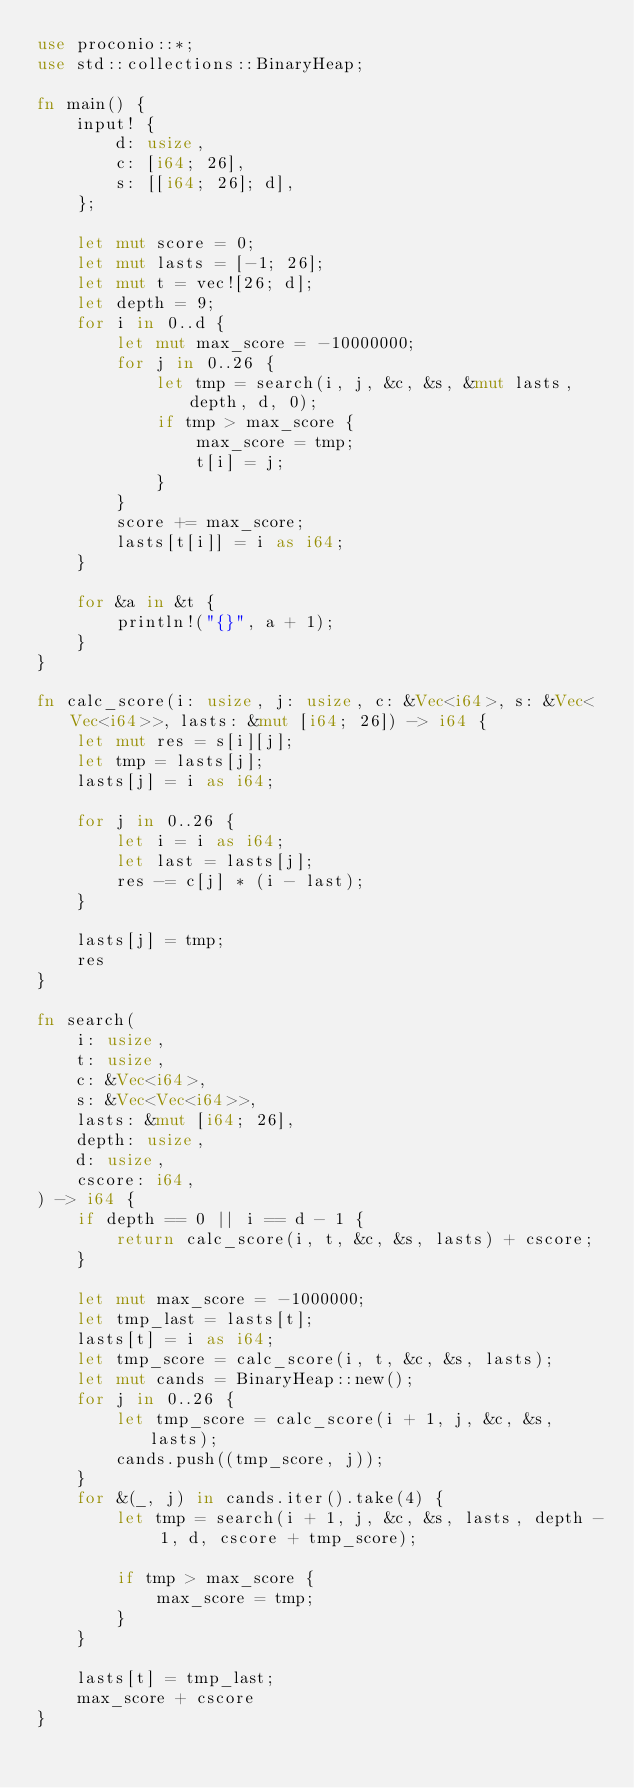Convert code to text. <code><loc_0><loc_0><loc_500><loc_500><_Rust_>use proconio::*;
use std::collections::BinaryHeap;

fn main() {
    input! {
        d: usize,
        c: [i64; 26],
        s: [[i64; 26]; d],
    };

    let mut score = 0;
    let mut lasts = [-1; 26];
    let mut t = vec![26; d];
    let depth = 9;
    for i in 0..d {
        let mut max_score = -10000000;
        for j in 0..26 {
            let tmp = search(i, j, &c, &s, &mut lasts, depth, d, 0);
            if tmp > max_score {
                max_score = tmp;
                t[i] = j;
            }
        }
        score += max_score;
        lasts[t[i]] = i as i64;
    }

    for &a in &t {
        println!("{}", a + 1);
    }
}

fn calc_score(i: usize, j: usize, c: &Vec<i64>, s: &Vec<Vec<i64>>, lasts: &mut [i64; 26]) -> i64 {
    let mut res = s[i][j];
    let tmp = lasts[j];
    lasts[j] = i as i64;

    for j in 0..26 {
        let i = i as i64;
        let last = lasts[j];
        res -= c[j] * (i - last);
    }

    lasts[j] = tmp;
    res
}

fn search(
    i: usize,
    t: usize,
    c: &Vec<i64>,
    s: &Vec<Vec<i64>>,
    lasts: &mut [i64; 26],
    depth: usize,
    d: usize,
    cscore: i64,
) -> i64 {
    if depth == 0 || i == d - 1 {
        return calc_score(i, t, &c, &s, lasts) + cscore;
    }

    let mut max_score = -1000000;
    let tmp_last = lasts[t];
    lasts[t] = i as i64;
    let tmp_score = calc_score(i, t, &c, &s, lasts);
    let mut cands = BinaryHeap::new();
    for j in 0..26 {
        let tmp_score = calc_score(i + 1, j, &c, &s, lasts);
        cands.push((tmp_score, j));
    }
    for &(_, j) in cands.iter().take(4) {
        let tmp = search(i + 1, j, &c, &s, lasts, depth - 1, d, cscore + tmp_score);

        if tmp > max_score {
            max_score = tmp;
        }
    }

    lasts[t] = tmp_last;
    max_score + cscore
}
</code> 